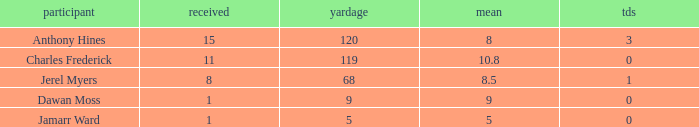What is the average number of TDs when the yards are less than 119, the AVG is larger than 5, and Jamarr Ward is a player? None. 